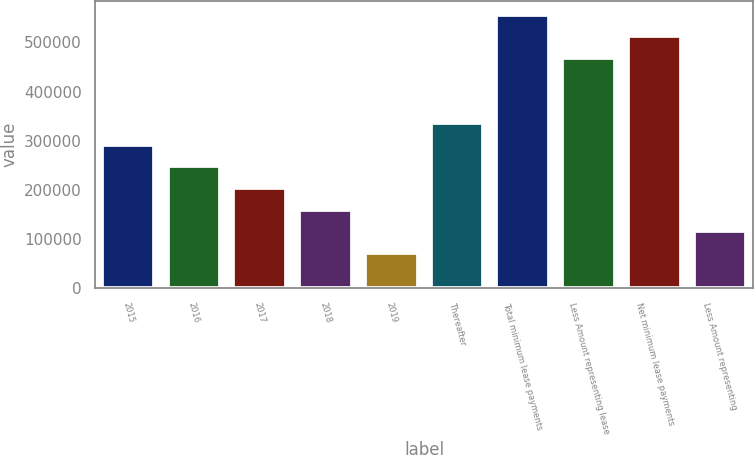<chart> <loc_0><loc_0><loc_500><loc_500><bar_chart><fcel>2015<fcel>2016<fcel>2017<fcel>2018<fcel>2019<fcel>Thereafter<fcel>Total minimum lease payments<fcel>Less Amount representing lease<fcel>Net minimum lease payments<fcel>Less Amount representing<nl><fcel>292282<fcel>248298<fcel>204314<fcel>160330<fcel>72362<fcel>336266<fcel>556186<fcel>468218<fcel>512202<fcel>116346<nl></chart> 